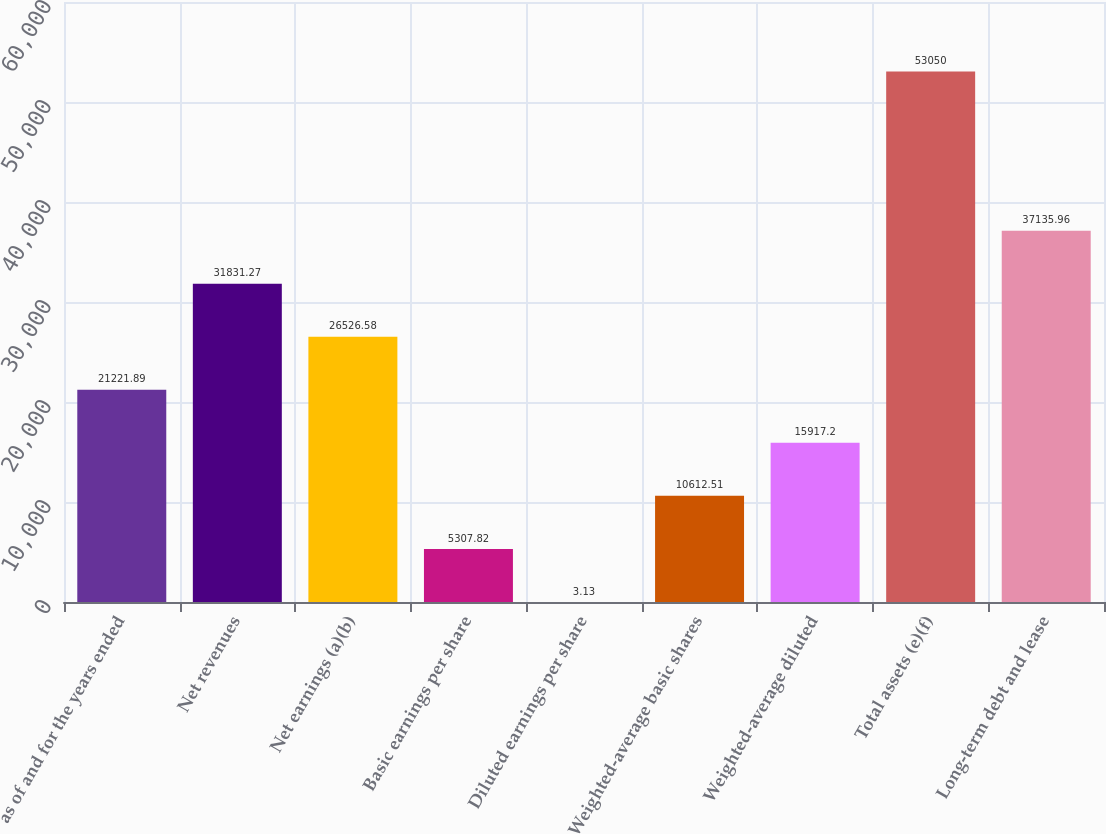<chart> <loc_0><loc_0><loc_500><loc_500><bar_chart><fcel>as of and for the years ended<fcel>Net revenues<fcel>Net earnings (a)(b)<fcel>Basic earnings per share<fcel>Diluted earnings per share<fcel>Weighted-average basic shares<fcel>Weighted-average diluted<fcel>Total assets (e)(f)<fcel>Long-term debt and lease<nl><fcel>21221.9<fcel>31831.3<fcel>26526.6<fcel>5307.82<fcel>3.13<fcel>10612.5<fcel>15917.2<fcel>53050<fcel>37136<nl></chart> 